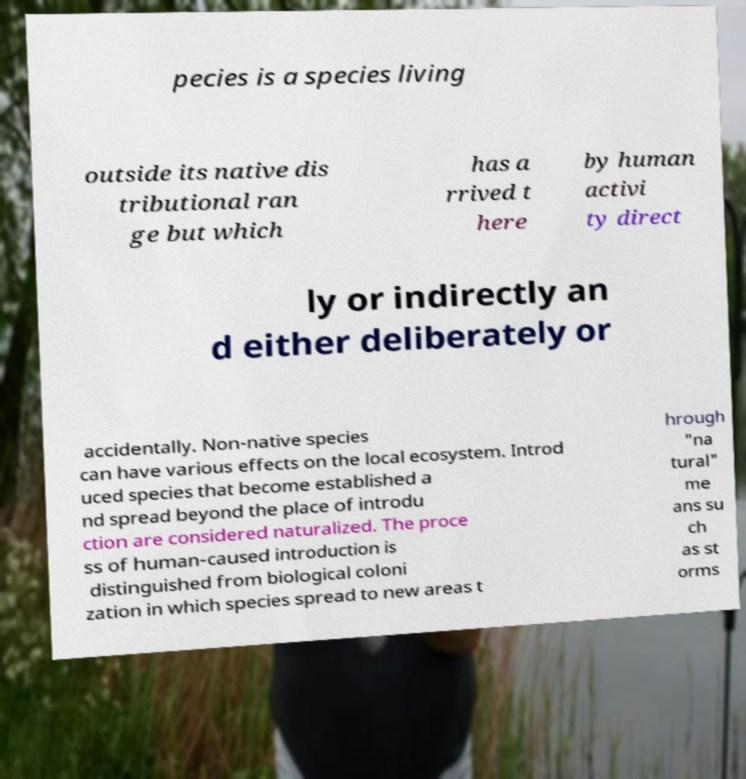Can you accurately transcribe the text from the provided image for me? pecies is a species living outside its native dis tributional ran ge but which has a rrived t here by human activi ty direct ly or indirectly an d either deliberately or accidentally. Non-native species can have various effects on the local ecosystem. Introd uced species that become established a nd spread beyond the place of introdu ction are considered naturalized. The proce ss of human-caused introduction is distinguished from biological coloni zation in which species spread to new areas t hrough "na tural" me ans su ch as st orms 